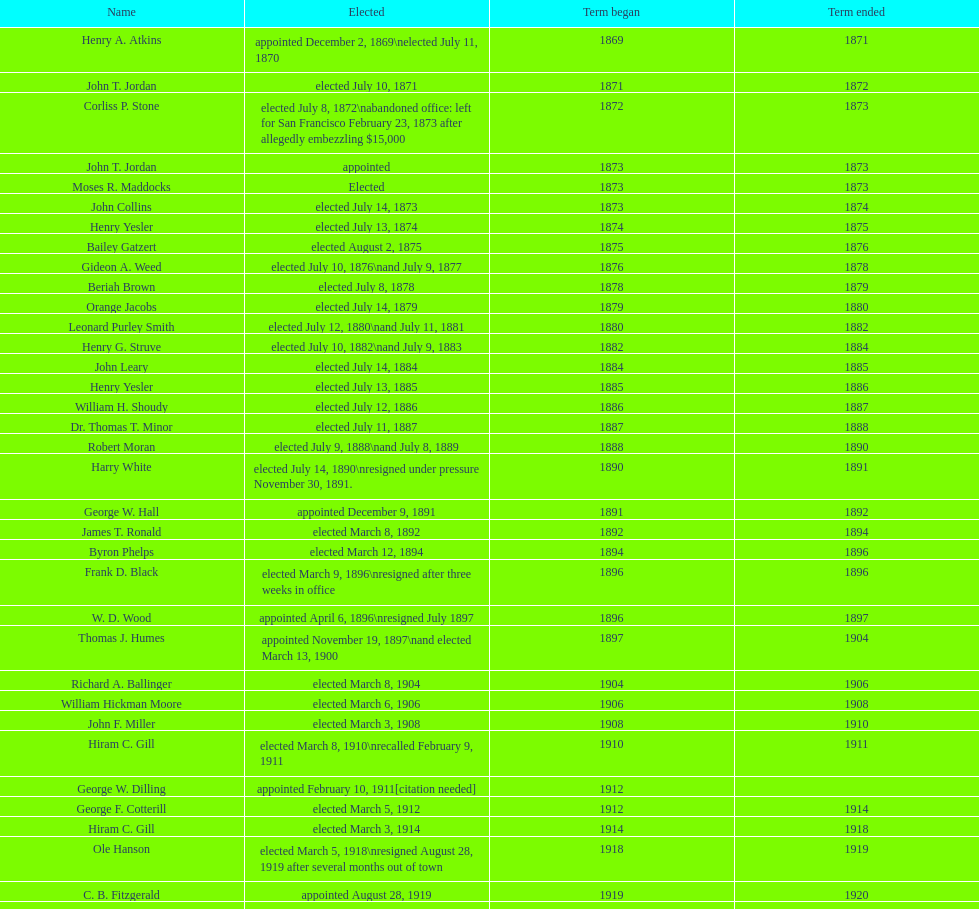Who held the position of mayor prior to jordan? Henry A. Atkins. 